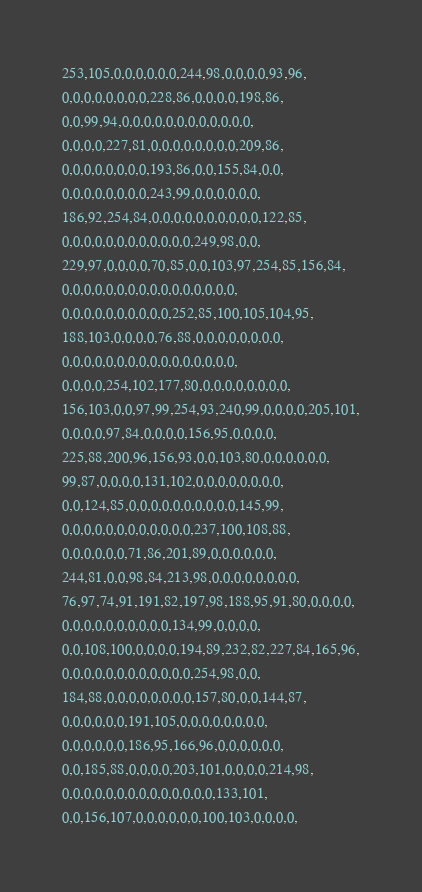<code> <loc_0><loc_0><loc_500><loc_500><_C_>253,105,0,0,0,0,0,0,244,98,0,0,0,0,93,96,
0,0,0,0,0,0,0,0,228,86,0,0,0,0,198,86,
0,0,99,94,0,0,0,0,0,0,0,0,0,0,0,0,
0,0,0,0,227,81,0,0,0,0,0,0,0,0,209,86,
0,0,0,0,0,0,0,0,193,86,0,0,155,84,0,0,
0,0,0,0,0,0,0,0,243,99,0,0,0,0,0,0,
186,92,254,84,0,0,0,0,0,0,0,0,0,0,122,85,
0,0,0,0,0,0,0,0,0,0,0,0,249,98,0,0,
229,97,0,0,0,0,70,85,0,0,103,97,254,85,156,84,
0,0,0,0,0,0,0,0,0,0,0,0,0,0,0,0,
0,0,0,0,0,0,0,0,0,0,252,85,100,105,104,95,
188,103,0,0,0,0,76,88,0,0,0,0,0,0,0,0,
0,0,0,0,0,0,0,0,0,0,0,0,0,0,0,0,
0,0,0,0,254,102,177,80,0,0,0,0,0,0,0,0,
156,103,0,0,97,99,254,93,240,99,0,0,0,0,205,101,
0,0,0,0,97,84,0,0,0,0,156,95,0,0,0,0,
225,88,200,96,156,93,0,0,103,80,0,0,0,0,0,0,
99,87,0,0,0,0,131,102,0,0,0,0,0,0,0,0,
0,0,124,85,0,0,0,0,0,0,0,0,0,0,145,99,
0,0,0,0,0,0,0,0,0,0,0,0,237,100,108,88,
0,0,0,0,0,0,71,86,201,89,0,0,0,0,0,0,
244,81,0,0,98,84,213,98,0,0,0,0,0,0,0,0,
76,97,74,91,191,82,197,98,188,95,91,80,0,0,0,0,
0,0,0,0,0,0,0,0,0,0,134,99,0,0,0,0,
0,0,108,100,0,0,0,0,194,89,232,82,227,84,165,96,
0,0,0,0,0,0,0,0,0,0,0,0,254,98,0,0,
184,88,0,0,0,0,0,0,0,0,157,80,0,0,144,87,
0,0,0,0,0,0,191,105,0,0,0,0,0,0,0,0,
0,0,0,0,0,0,186,95,166,96,0,0,0,0,0,0,
0,0,185,88,0,0,0,0,203,101,0,0,0,0,214,98,
0,0,0,0,0,0,0,0,0,0,0,0,0,0,133,101,
0,0,156,107,0,0,0,0,0,0,100,103,0,0,0,0,</code> 